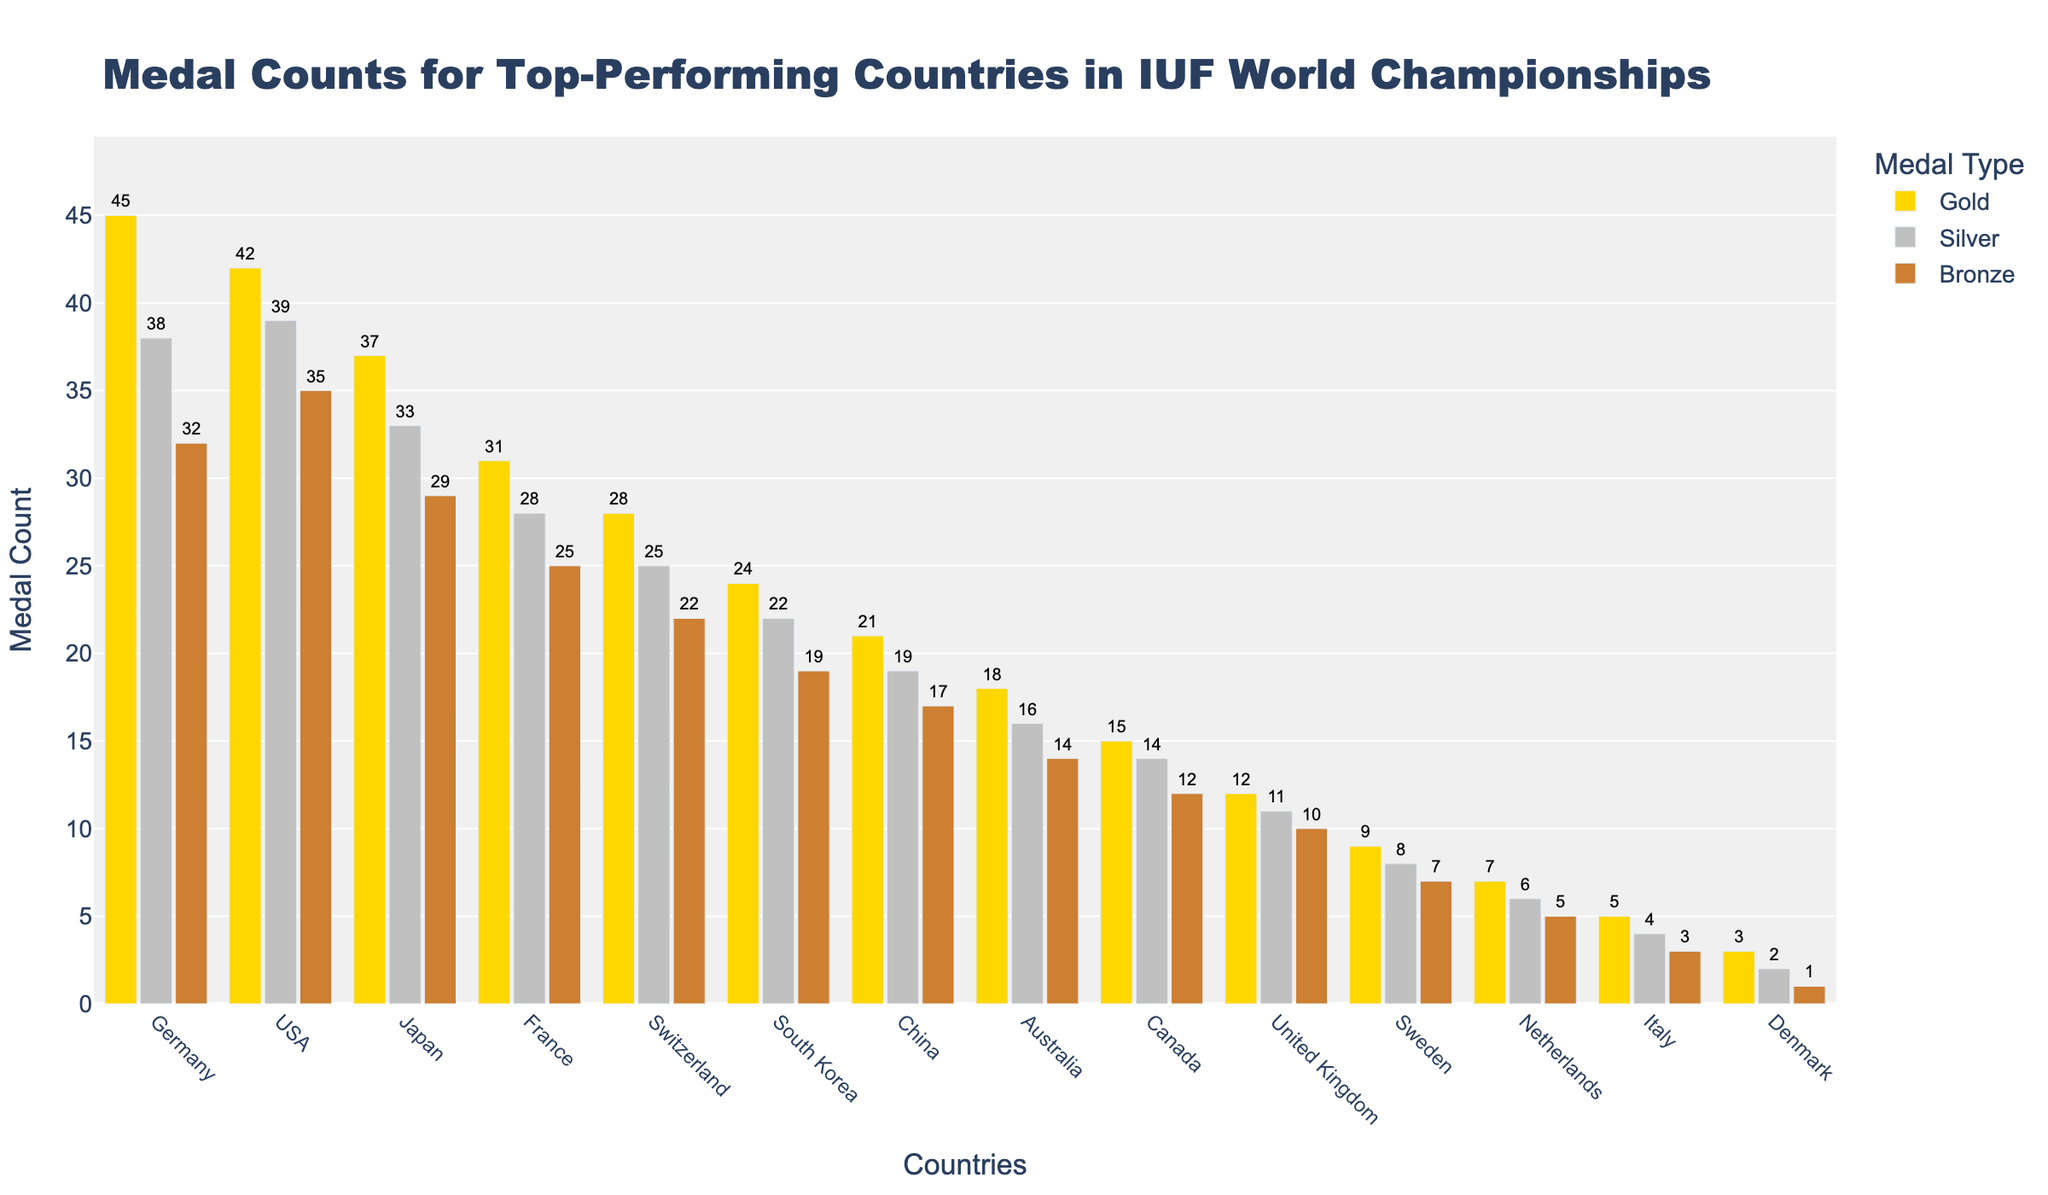Which country has the highest number of gold medals? The highest bar in the Gold medal category is for Germany, indicating they won the highest number of gold medals.
Answer: Germany Which country won more silver medals, USA or Japan? Comparing the Silver medal bars, the USA's bar is taller than Japan's bar, indicating that the USA won more silver medals.
Answer: USA How many medals in total did France win? Adding France's medals: 31 Gold + 28 Silver + 25 Bronze = 84
Answer: 84 Which country has fewer bronze medals, Switzerland or South Korea? The Bronze medal bar for South Korea is taller than Switzerland's, indicating Switzerland has fewer Bronze medals.
Answer: Switzerland What is the difference in total medals between Canada and the United Kingdom? Calculating total medals for both: Canada: 15+14+12=41, United Kingdom: 12+11+10=33. The difference is 41 - 33 = 8
Answer: 8 Is there any country with an equal number of gold and bronze medals? By examining the bars for Gold and Bronze medals, there is no country where the bars for Gold and Bronze medals are of equal height.
Answer: No Which country has the third most number of total medals? Calculating total medals for each country and sorting: Germany (115), USA (116), Japan (99), France (84), ... The third most is Japan with 99 medals.
Answer: Japan What is the ratio of gold to silver medals for Australia? Australia has 18 Gold and 16 Silver medals, so the ratio is 18/16 which simplifies to 9/8.
Answer: 9/8 Which country won more medals overall, China or South Korea? Calculating total medals: China (21+19+17=57) and South Korea (24+22+19=65). South Korea has more medals overall.
Answer: South Korea 